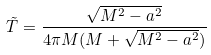Convert formula to latex. <formula><loc_0><loc_0><loc_500><loc_500>\tilde { T } = \frac { \sqrt { M ^ { 2 } - a ^ { 2 } } } { 4 \pi M ( M + \sqrt { M ^ { 2 } - a ^ { 2 } } ) }</formula> 